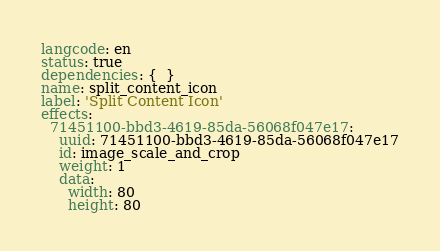Convert code to text. <code><loc_0><loc_0><loc_500><loc_500><_YAML_>langcode: en
status: true
dependencies: {  }
name: split_content_icon
label: 'Split Content Icon'
effects:
  71451100-bbd3-4619-85da-56068f047e17:
    uuid: 71451100-bbd3-4619-85da-56068f047e17
    id: image_scale_and_crop
    weight: 1
    data:
      width: 80
      height: 80
</code> 